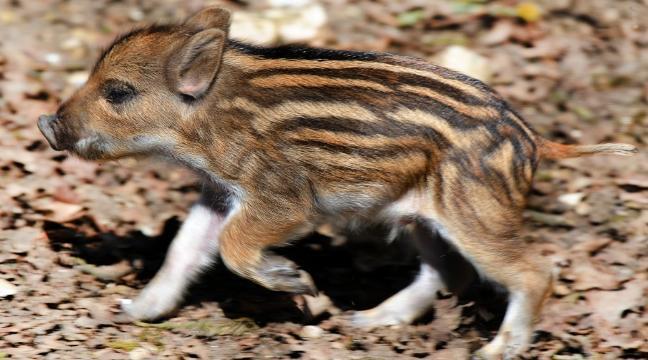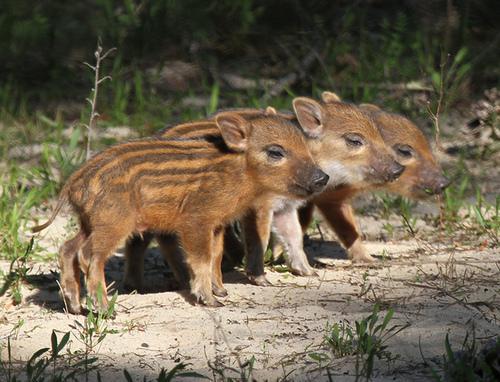The first image is the image on the left, the second image is the image on the right. Considering the images on both sides, is "There are at most three boar piglets." valid? Answer yes or no. No. The first image is the image on the left, the second image is the image on the right. Analyze the images presented: Is the assertion "There are more pigs in the right image than in the left image." valid? Answer yes or no. Yes. 